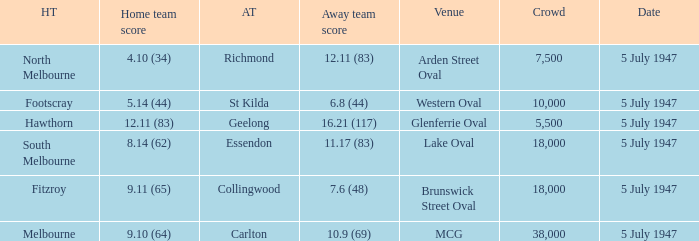What home team played an away team with a score of 6.8 (44)? Footscray. 